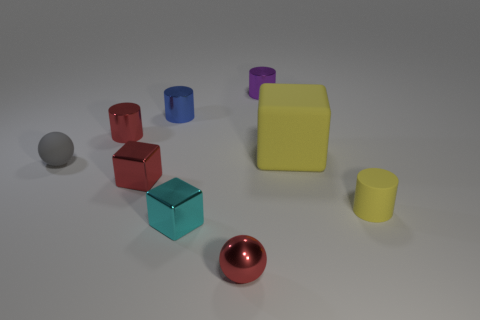Subtract all red metallic cubes. How many cubes are left? 2 Add 1 tiny green cylinders. How many objects exist? 10 Subtract all red cylinders. How many cylinders are left? 3 Subtract 1 cubes. How many cubes are left? 2 Subtract all tiny red shiny balls. Subtract all blue metallic objects. How many objects are left? 7 Add 9 purple things. How many purple things are left? 10 Add 2 big brown metal cylinders. How many big brown metal cylinders exist? 2 Subtract 0 brown balls. How many objects are left? 9 Subtract all blocks. How many objects are left? 6 Subtract all purple blocks. Subtract all green balls. How many blocks are left? 3 